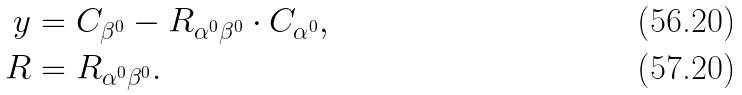<formula> <loc_0><loc_0><loc_500><loc_500>y & = C _ { \beta ^ { 0 } } - R _ { \alpha ^ { 0 } \beta ^ { 0 } } \cdot C _ { \alpha ^ { 0 } } , \\ R & = R _ { \alpha ^ { 0 } \beta ^ { 0 } } .</formula> 